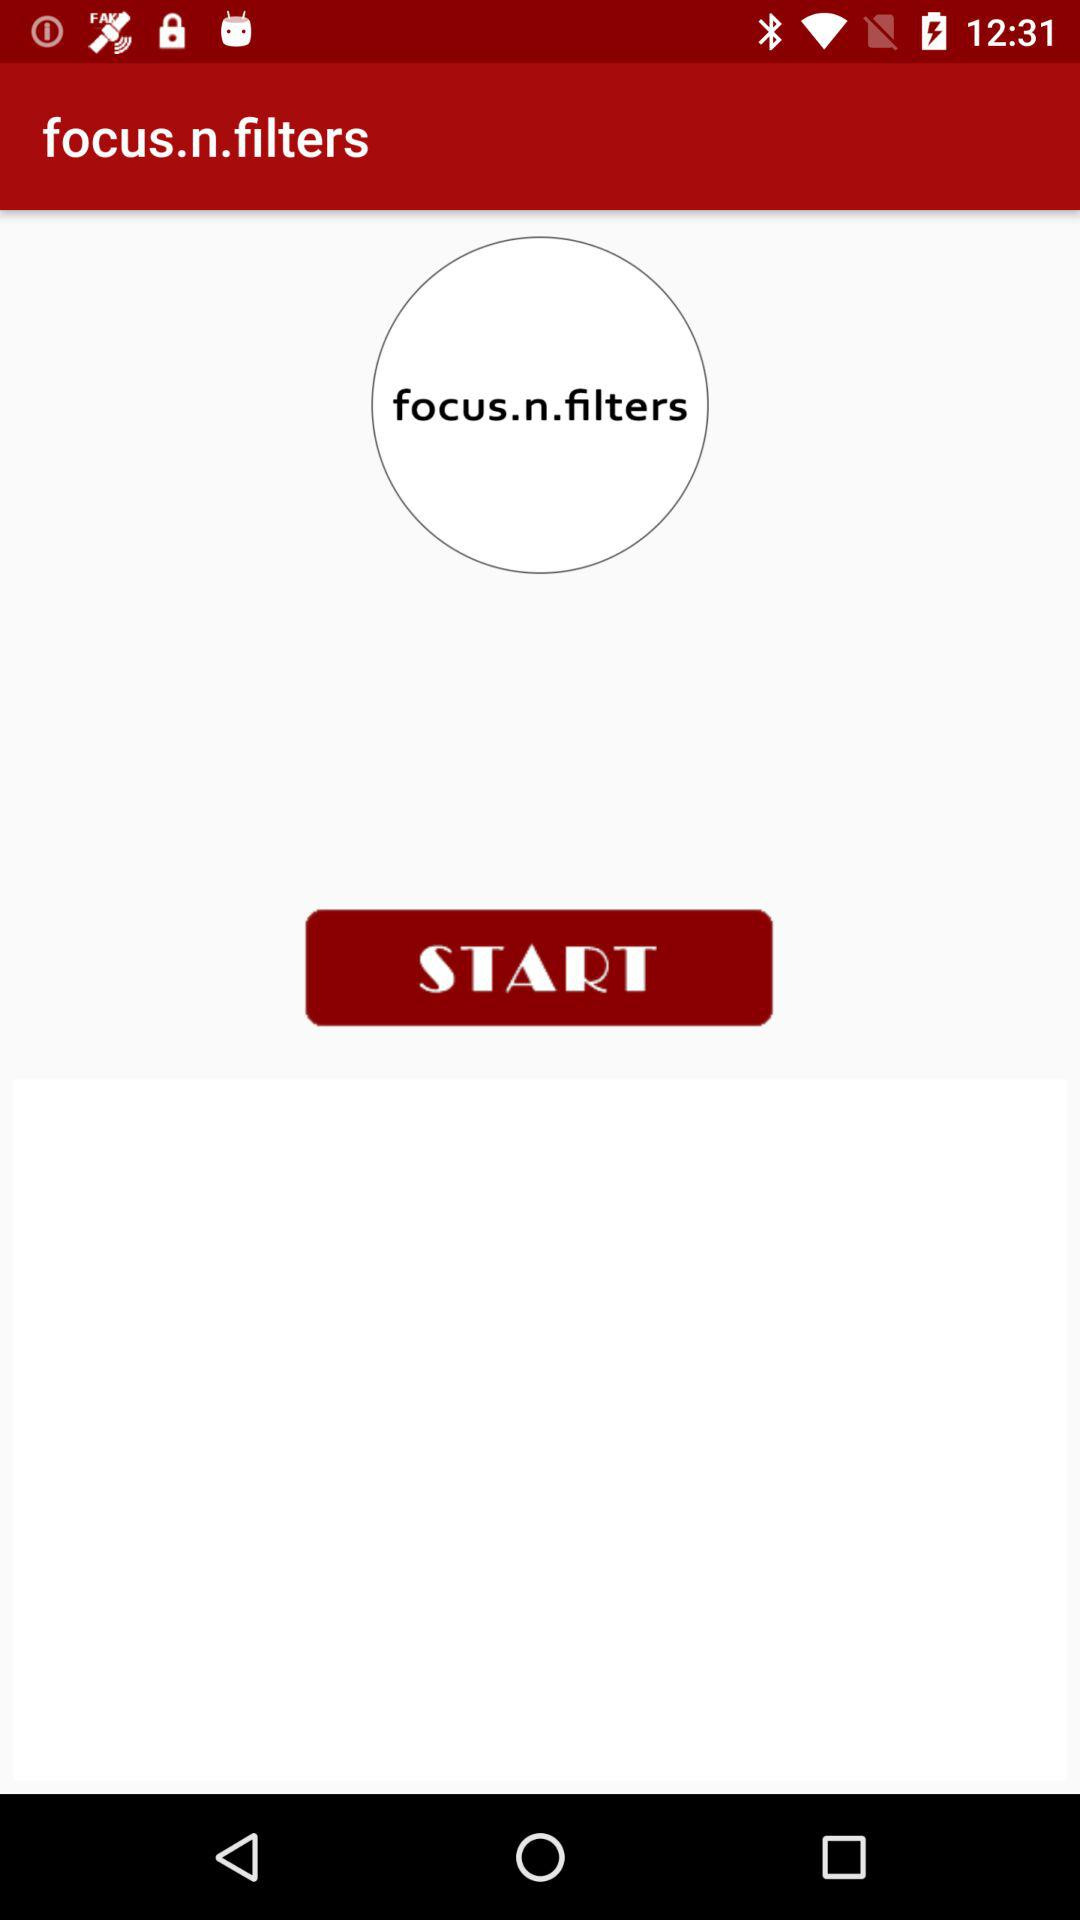What is the application name? The application name is "focus.n.filters". 